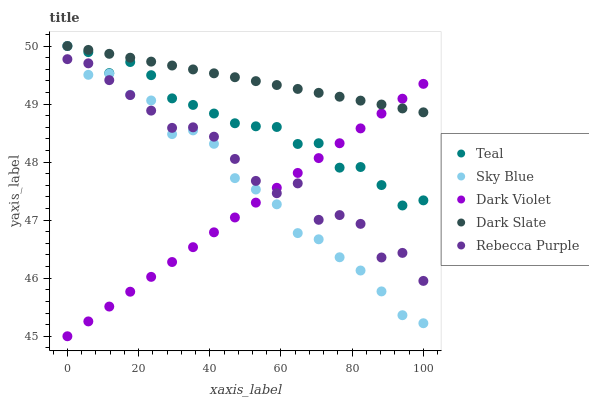Does Dark Violet have the minimum area under the curve?
Answer yes or no. Yes. Does Dark Slate have the maximum area under the curve?
Answer yes or no. Yes. Does Rebecca Purple have the minimum area under the curve?
Answer yes or no. No. Does Rebecca Purple have the maximum area under the curve?
Answer yes or no. No. Is Dark Violet the smoothest?
Answer yes or no. Yes. Is Rebecca Purple the roughest?
Answer yes or no. Yes. Is Rebecca Purple the smoothest?
Answer yes or no. No. Is Dark Violet the roughest?
Answer yes or no. No. Does Dark Violet have the lowest value?
Answer yes or no. Yes. Does Rebecca Purple have the lowest value?
Answer yes or no. No. Does Dark Slate have the highest value?
Answer yes or no. Yes. Does Rebecca Purple have the highest value?
Answer yes or no. No. Is Rebecca Purple less than Dark Slate?
Answer yes or no. Yes. Is Teal greater than Rebecca Purple?
Answer yes or no. Yes. Does Teal intersect Sky Blue?
Answer yes or no. Yes. Is Teal less than Sky Blue?
Answer yes or no. No. Is Teal greater than Sky Blue?
Answer yes or no. No. Does Rebecca Purple intersect Dark Slate?
Answer yes or no. No. 